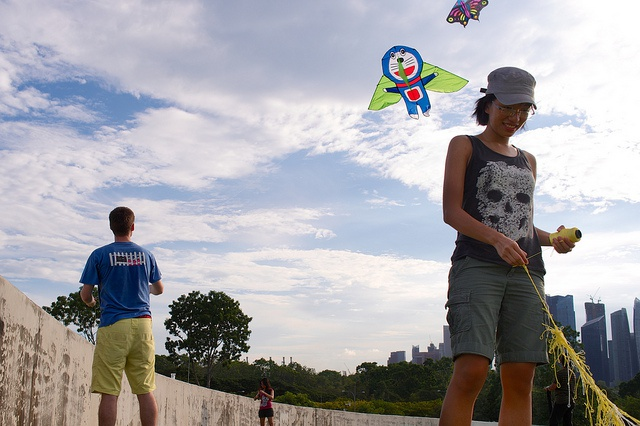Describe the objects in this image and their specific colors. I can see people in darkgray, black, maroon, and gray tones, people in darkgray, olive, navy, black, and maroon tones, kite in darkgray, lightgreen, lightgray, blue, and red tones, kite in darkgray, gray, black, navy, and purple tones, and people in darkgray, black, maroon, gray, and brown tones in this image. 